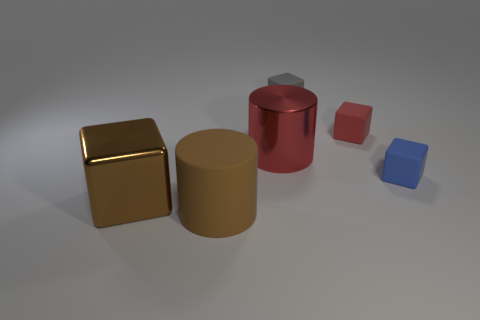Is the large cylinder that is in front of the blue rubber cube made of the same material as the small cube in front of the red cylinder?
Offer a very short reply. Yes. What number of tiny brown matte cubes are there?
Your answer should be very brief. 0. How many other objects are the same shape as the large red object?
Offer a very short reply. 1. Do the brown shiny object and the tiny gray thing have the same shape?
Make the answer very short. Yes. The gray matte thing is what size?
Your answer should be compact. Small. How many rubber cylinders have the same size as the brown block?
Make the answer very short. 1. Does the red thing that is to the right of the red metallic cylinder have the same size as the matte object left of the tiny gray cube?
Your answer should be very brief. No. What shape is the gray matte object that is behind the blue object?
Ensure brevity in your answer.  Cube. There is a cylinder behind the small rubber cube on the right side of the red matte object; what is its material?
Make the answer very short. Metal. Is there a matte thing of the same color as the big cube?
Make the answer very short. Yes. 